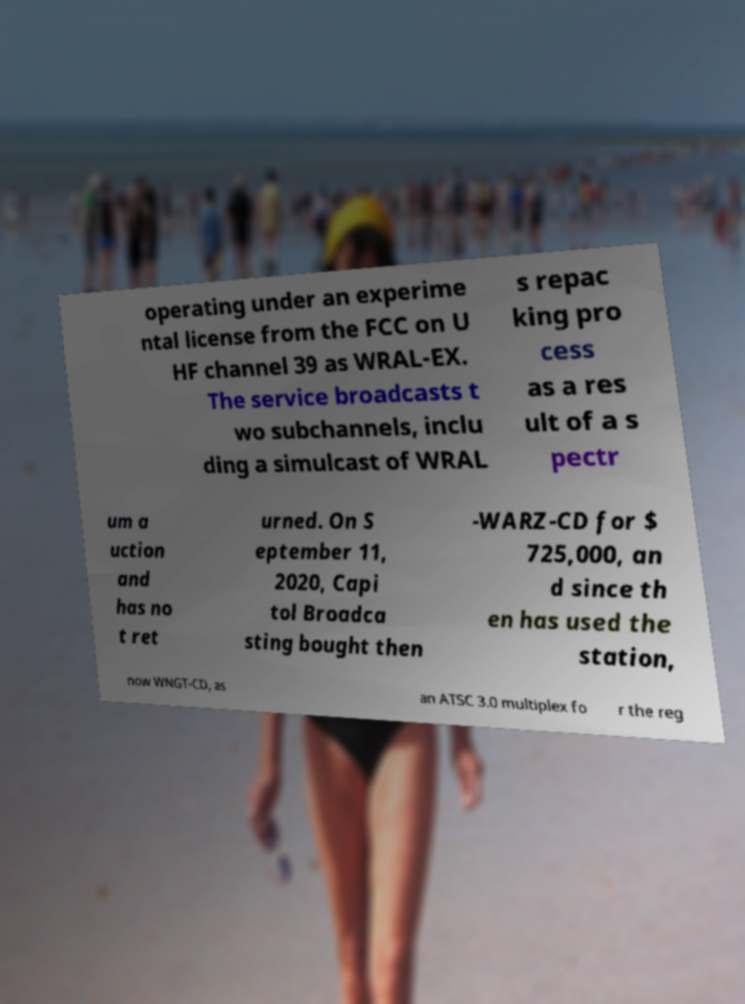For documentation purposes, I need the text within this image transcribed. Could you provide that? operating under an experime ntal license from the FCC on U HF channel 39 as WRAL-EX. The service broadcasts t wo subchannels, inclu ding a simulcast of WRAL s repac king pro cess as a res ult of a s pectr um a uction and has no t ret urned. On S eptember 11, 2020, Capi tol Broadca sting bought then -WARZ-CD for $ 725,000, an d since th en has used the station, now WNGT-CD, as an ATSC 3.0 multiplex fo r the reg 